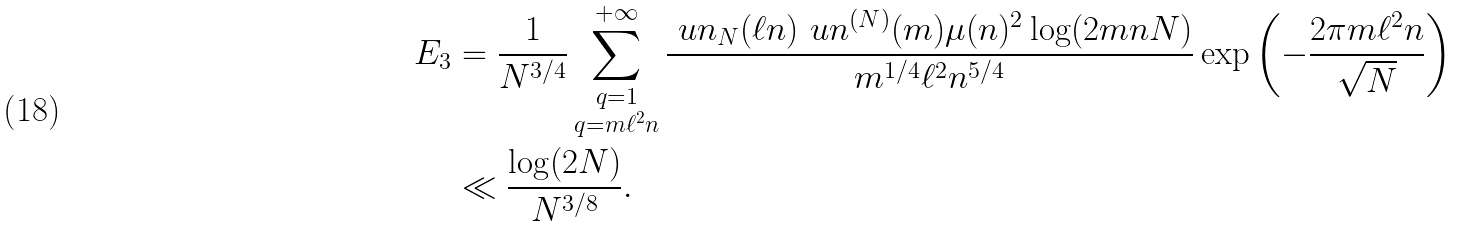<formula> <loc_0><loc_0><loc_500><loc_500>E _ { 3 } & = \frac { 1 } { N ^ { 3 / 4 } } \sum _ { \substack { q = 1 \\ q = m \ell ^ { 2 } n } } ^ { + \infty } \frac { \ u n _ { N } ( \ell n ) \ u n ^ { ( N ) } ( m ) \mu ( n ) ^ { 2 } \log ( 2 m n N ) } { m ^ { 1 / 4 } \ell ^ { 2 } n ^ { 5 / 4 } } \exp \left ( - \frac { 2 \pi m \ell ^ { 2 } n } { \sqrt { N } } \right ) \\ & \ll \frac { \log ( 2 N ) } { N ^ { 3 / 8 } } .</formula> 